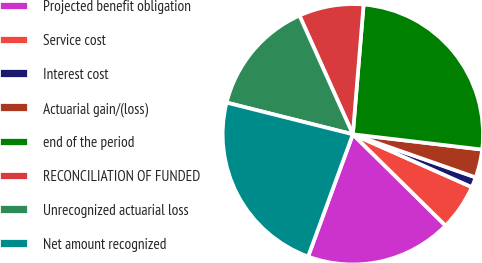<chart> <loc_0><loc_0><loc_500><loc_500><pie_chart><fcel>Projected benefit obligation<fcel>Service cost<fcel>Interest cost<fcel>Actuarial gain/(loss)<fcel>end of the period<fcel>RECONCILIATION OF FUNDED<fcel>Unrecognized actuarial loss<fcel>Net amount recognized<nl><fcel>18.2%<fcel>5.73%<fcel>1.28%<fcel>3.5%<fcel>25.55%<fcel>8.04%<fcel>14.36%<fcel>23.33%<nl></chart> 